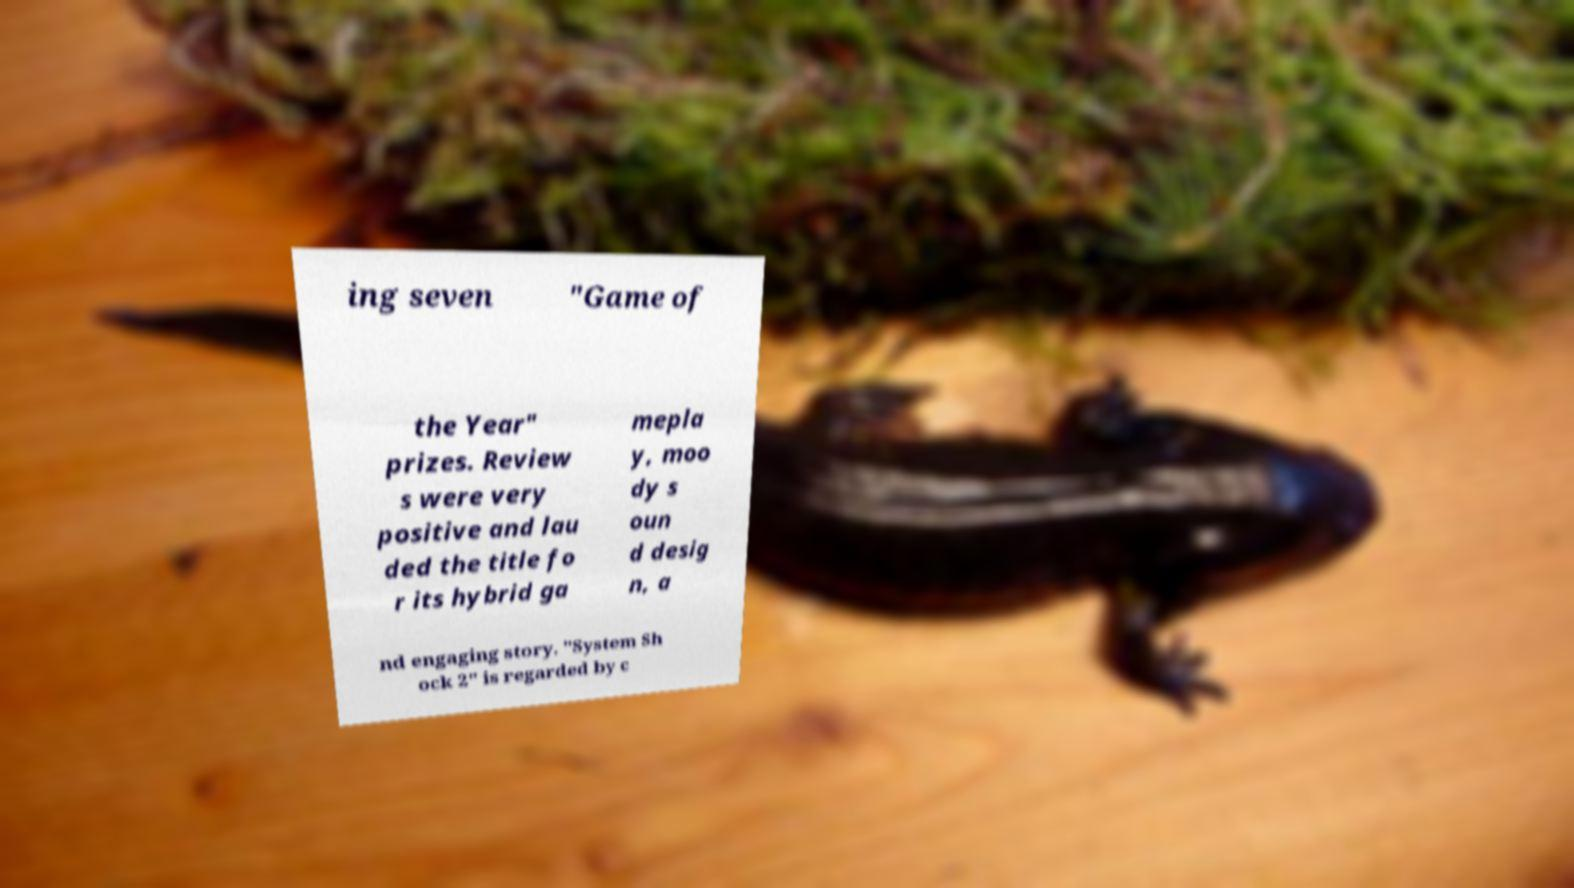Could you assist in decoding the text presented in this image and type it out clearly? ing seven "Game of the Year" prizes. Review s were very positive and lau ded the title fo r its hybrid ga mepla y, moo dy s oun d desig n, a nd engaging story. "System Sh ock 2" is regarded by c 